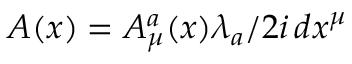<formula> <loc_0><loc_0><loc_500><loc_500>A ( x ) = A _ { \mu } ^ { a } ( x ) \lambda _ { a } / 2 i \, d x ^ { \mu }</formula> 